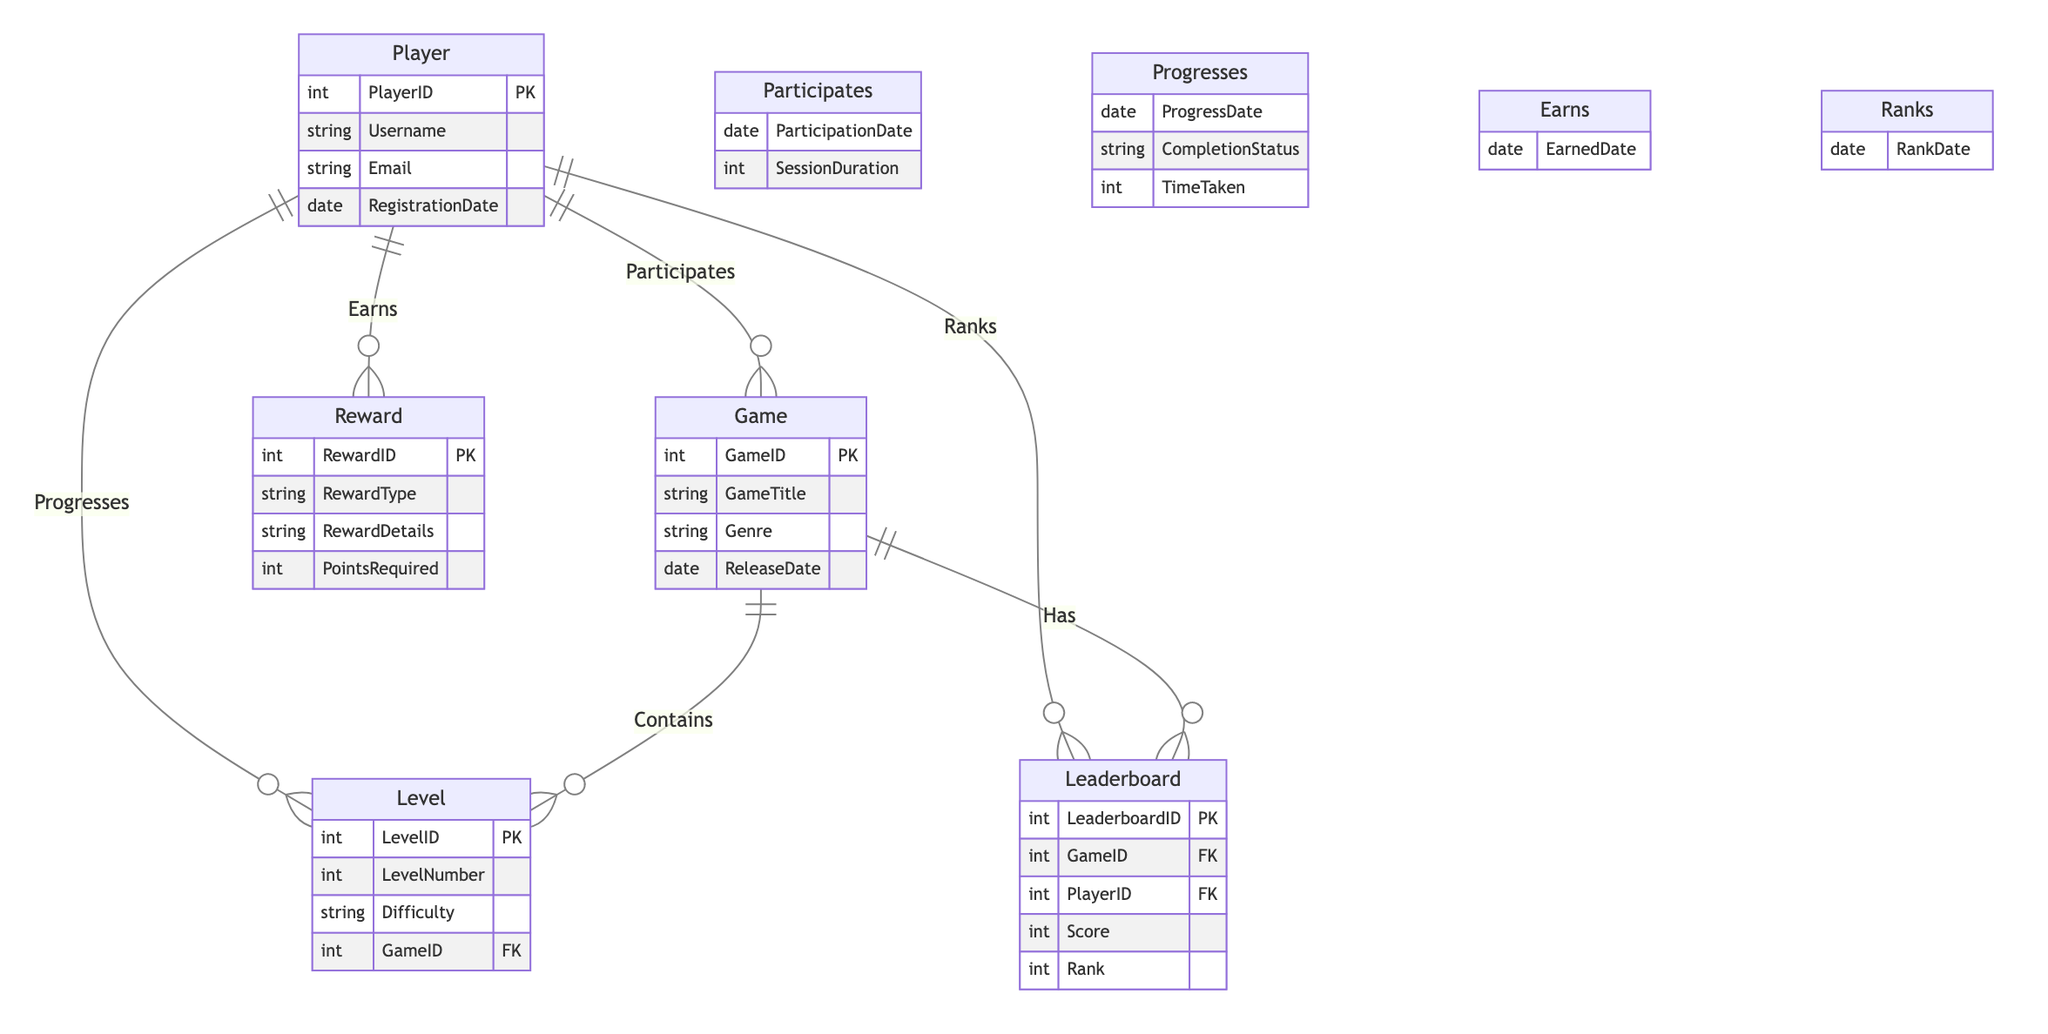What is the primary key of the Player entity? The primary key of the Player entity is PlayerID, which uniquely identifies each player in the database as indicated by 'PK' next to PlayerID in the diagram.
Answer: PlayerID How many attributes does the Reward entity have? The Reward entity has four attributes: RewardID, RewardType, RewardDetails, and PointsRequired, as seen in the attribute list for Reward in the diagram.
Answer: 4 What relationship exists between Player and Game? The relationship that exists between Player and Game is "Participates," which implies that players engage in one or more games, as indicated by the labeling of the relationship in the diagram.
Answer: Participates What attribute indicates when a player progresses to a new level? The attribute that indicates when a player progresses to a new level is ProgressDate, as shown in the 'Progresses' relationship attributes connecting Player and Level in the diagram.
Answer: ProgressDate Which entity contains the many-to-one relationship with Level? The entity that contains the many-to-one relationship with Level is Game, as indicated by the line connecting Level and Game with the notation showing that multiple levels can belong to a single game.
Answer: Game What type of relationship is established between Player and Reward? The relationship established between Player and Reward is "Earns," signifying that players can earn multiple rewards, according to the relationships defined in the diagram.
Answer: Earns How many entities are connected to Leaderboard? Four entities are connected to Leaderboard: Player, Game, and it's directly involved in the Ranks relationship with Player and Has relationship with Game, indicating a broader interactive structure with players and games.
Answer: 2 What attribute indicates the score on the Leaderboard? The attribute that indicates the score on the Leaderboard is Score, which is explicitly listed in the attributes of the Leaderboard entity in the diagram.
Answer: Score In what context do players earn rewards? Players earn rewards in the context of the "Earns" relationship, which connects them to the Reward entity as shown in the diagram, specifically capturing when rewards are awarded to players.
Answer: Earns 